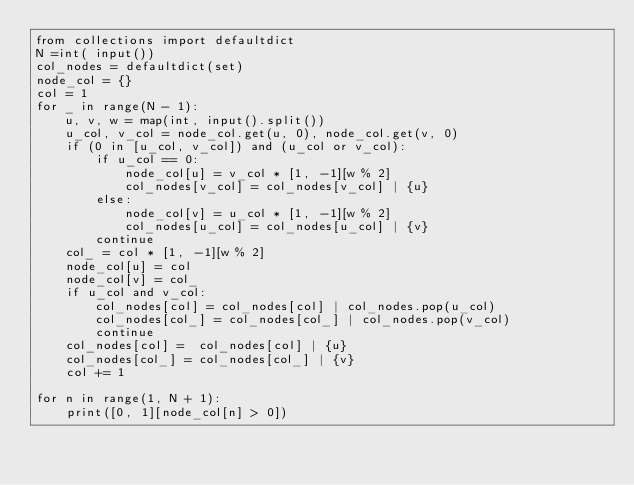<code> <loc_0><loc_0><loc_500><loc_500><_Python_>from collections import defaultdict
N =int( input())
col_nodes = defaultdict(set)
node_col = {}
col = 1
for _ in range(N - 1):
    u, v, w = map(int, input().split())
    u_col, v_col = node_col.get(u, 0), node_col.get(v, 0)
    if (0 in [u_col, v_col]) and (u_col or v_col):
        if u_col == 0:
            node_col[u] = v_col * [1, -1][w % 2]
            col_nodes[v_col] = col_nodes[v_col] | {u}
        else:
            node_col[v] = u_col * [1, -1][w % 2]
            col_nodes[u_col] = col_nodes[u_col] | {v}
        continue
    col_ = col * [1, -1][w % 2]
    node_col[u] = col
    node_col[v] = col_
    if u_col and v_col:
        col_nodes[col] = col_nodes[col] | col_nodes.pop(u_col)
        col_nodes[col_] = col_nodes[col_] | col_nodes.pop(v_col)
        continue
    col_nodes[col] =  col_nodes[col] | {u}
    col_nodes[col_] = col_nodes[col_] | {v}
    col += 1
        
for n in range(1, N + 1):
    print([0, 1][node_col[n] > 0])</code> 